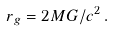<formula> <loc_0><loc_0><loc_500><loc_500>r _ { g } = 2 M G / c ^ { 2 } \, .</formula> 